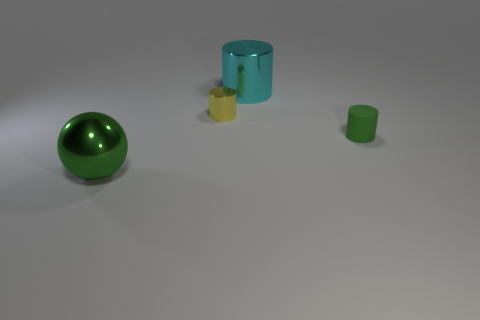Add 2 big red matte cylinders. How many objects exist? 6 Subtract all green cylinders. How many cylinders are left? 2 Subtract all cyan cylinders. How many cylinders are left? 2 Subtract all big green metal spheres. Subtract all tiny objects. How many objects are left? 1 Add 1 cyan cylinders. How many cyan cylinders are left? 2 Add 4 yellow cylinders. How many yellow cylinders exist? 5 Subtract 0 gray blocks. How many objects are left? 4 Subtract all cylinders. How many objects are left? 1 Subtract all red cylinders. Subtract all green balls. How many cylinders are left? 3 Subtract all red balls. How many purple cylinders are left? 0 